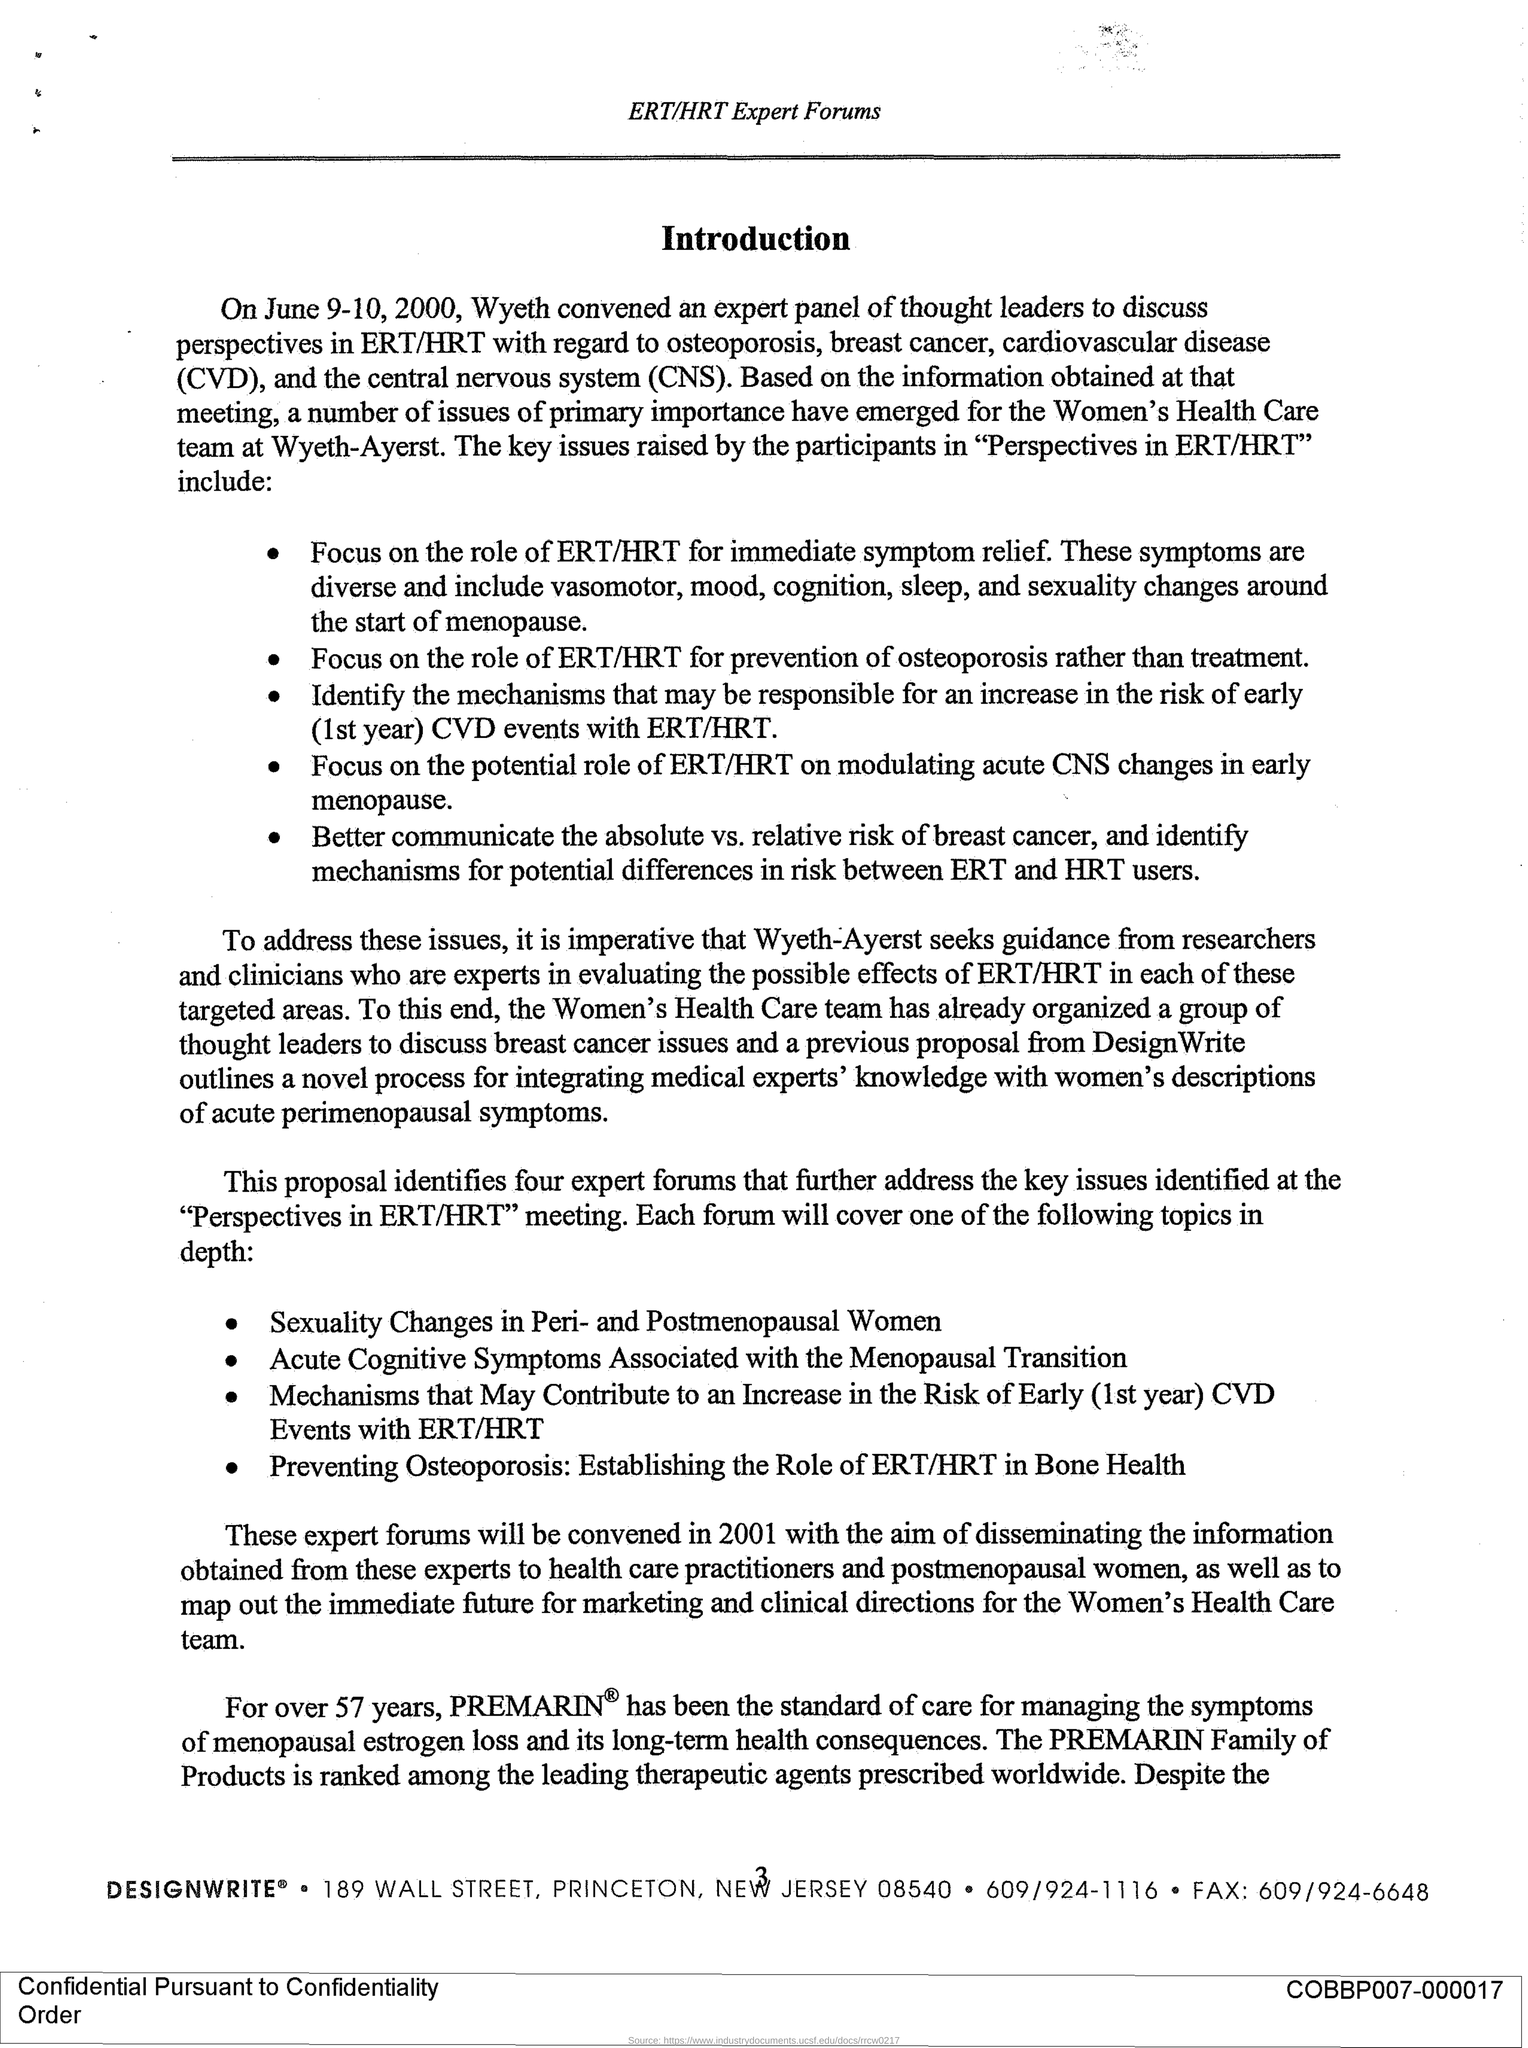Mention a couple of crucial points in this snapshot. For 57 years, PREMARIN has been the standard of care for managing symptoms of menopausal estrogen loss. Cardiovascular disease is a condition that affects the heart and blood vessels. On June 9-10, 2000, Wyeth convened an expert panel of thought leaders to discuss relevant topics. The abbreviation "CNS" is commonly used to refer to the Central Nervous System, which consists of the brain and spinal cord and is responsible for controlling and coordinating the body's functions. 